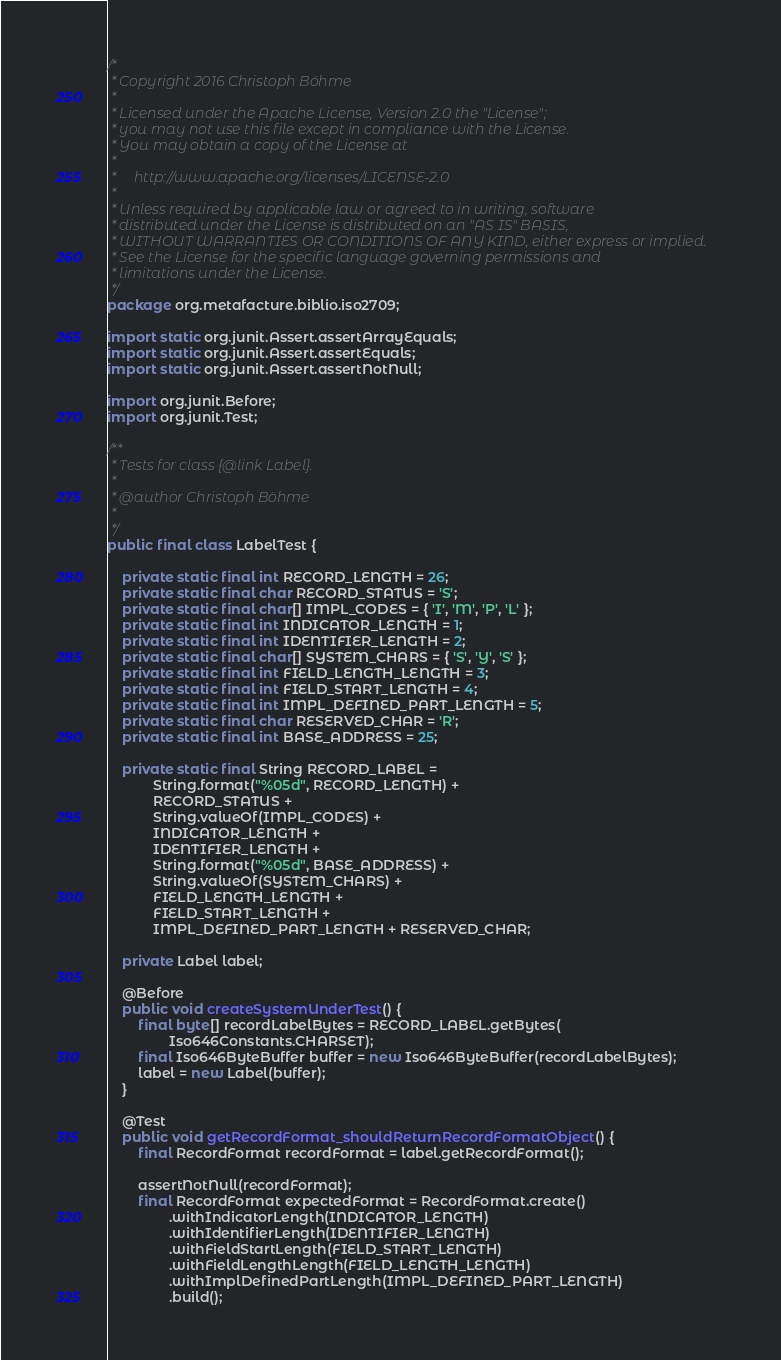Convert code to text. <code><loc_0><loc_0><loc_500><loc_500><_Java_>/*
 * Copyright 2016 Christoph Böhme
 *
 * Licensed under the Apache License, Version 2.0 the "License";
 * you may not use this file except in compliance with the License.
 * You may obtain a copy of the License at
 *
 *     http://www.apache.org/licenses/LICENSE-2.0
 *
 * Unless required by applicable law or agreed to in writing, software
 * distributed under the License is distributed on an "AS IS" BASIS,
 * WITHOUT WARRANTIES OR CONDITIONS OF ANY KIND, either express or implied.
 * See the License for the specific language governing permissions and
 * limitations under the License.
 */
package org.metafacture.biblio.iso2709;

import static org.junit.Assert.assertArrayEquals;
import static org.junit.Assert.assertEquals;
import static org.junit.Assert.assertNotNull;

import org.junit.Before;
import org.junit.Test;

/**
 * Tests for class {@link Label}.
 *
 * @author Christoph Böhme
 *
 */
public final class LabelTest {

	private static final int RECORD_LENGTH = 26;
	private static final char RECORD_STATUS = 'S';
	private static final char[] IMPL_CODES = { 'I', 'M', 'P', 'L' };
	private static final int INDICATOR_LENGTH = 1;
	private static final int IDENTIFIER_LENGTH = 2;
	private static final char[] SYSTEM_CHARS = { 'S', 'Y', 'S' };
	private static final int FIELD_LENGTH_LENGTH = 3;
	private static final int FIELD_START_LENGTH = 4;
	private static final int IMPL_DEFINED_PART_LENGTH = 5;
	private static final char RESERVED_CHAR = 'R';
	private static final int BASE_ADDRESS = 25;

	private static final String RECORD_LABEL =
			String.format("%05d", RECORD_LENGTH) +
			RECORD_STATUS +
			String.valueOf(IMPL_CODES) +
			INDICATOR_LENGTH +
			IDENTIFIER_LENGTH +
			String.format("%05d", BASE_ADDRESS) +
			String.valueOf(SYSTEM_CHARS) +
			FIELD_LENGTH_LENGTH +
			FIELD_START_LENGTH +
			IMPL_DEFINED_PART_LENGTH + RESERVED_CHAR;

	private Label label;

	@Before
	public void createSystemUnderTest() {
		final byte[] recordLabelBytes = RECORD_LABEL.getBytes(
				Iso646Constants.CHARSET);
		final Iso646ByteBuffer buffer = new Iso646ByteBuffer(recordLabelBytes);
		label = new Label(buffer);
	}

	@Test
	public void getRecordFormat_shouldReturnRecordFormatObject() {
		final RecordFormat recordFormat = label.getRecordFormat();

		assertNotNull(recordFormat);
		final RecordFormat expectedFormat = RecordFormat.create()
				.withIndicatorLength(INDICATOR_LENGTH)
				.withIdentifierLength(IDENTIFIER_LENGTH)
				.withFieldStartLength(FIELD_START_LENGTH)
				.withFieldLengthLength(FIELD_LENGTH_LENGTH)
				.withImplDefinedPartLength(IMPL_DEFINED_PART_LENGTH)
				.build();</code> 